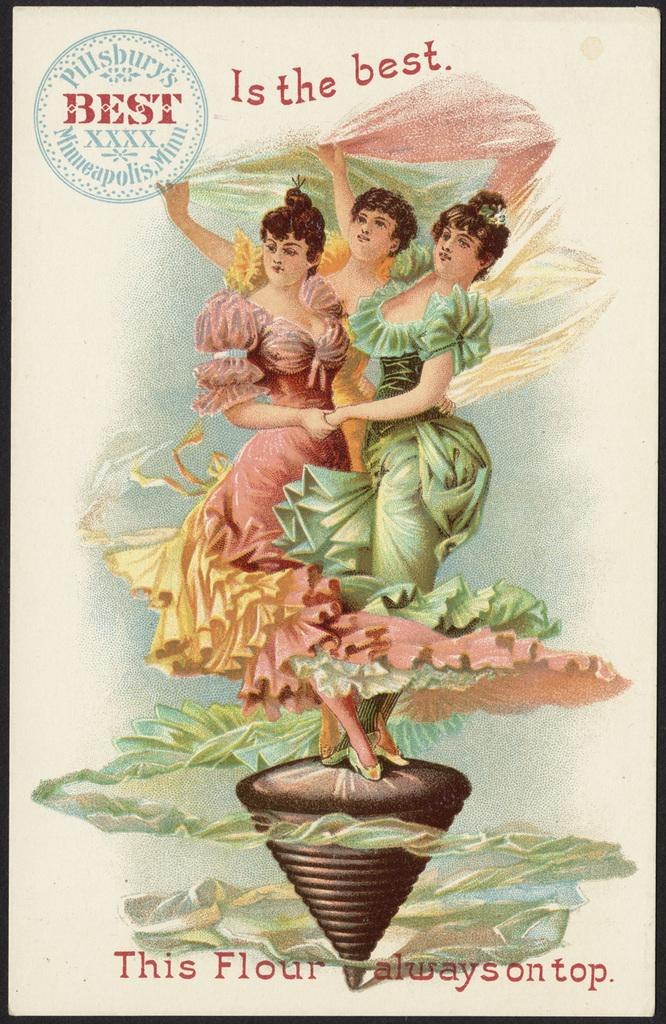<image>
Share a concise interpretation of the image provided. Poster showing three women on a top with the words "This Flour always on top". 